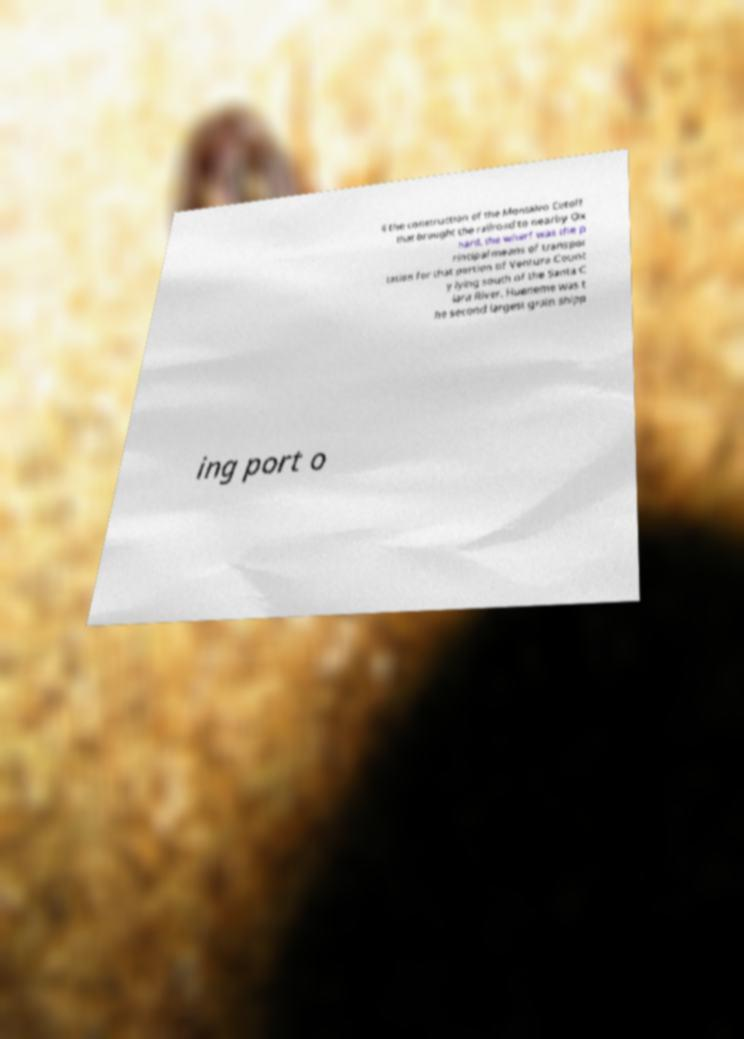Please read and relay the text visible in this image. What does it say? il the construction of the Montalvo Cutoff that brought the railroad to nearby Ox nard, the wharf was the p rincipal means of transpor tation for that portion of Ventura Count y lying south of the Santa C lara River. Hueneme was t he second largest grain shipp ing port o 